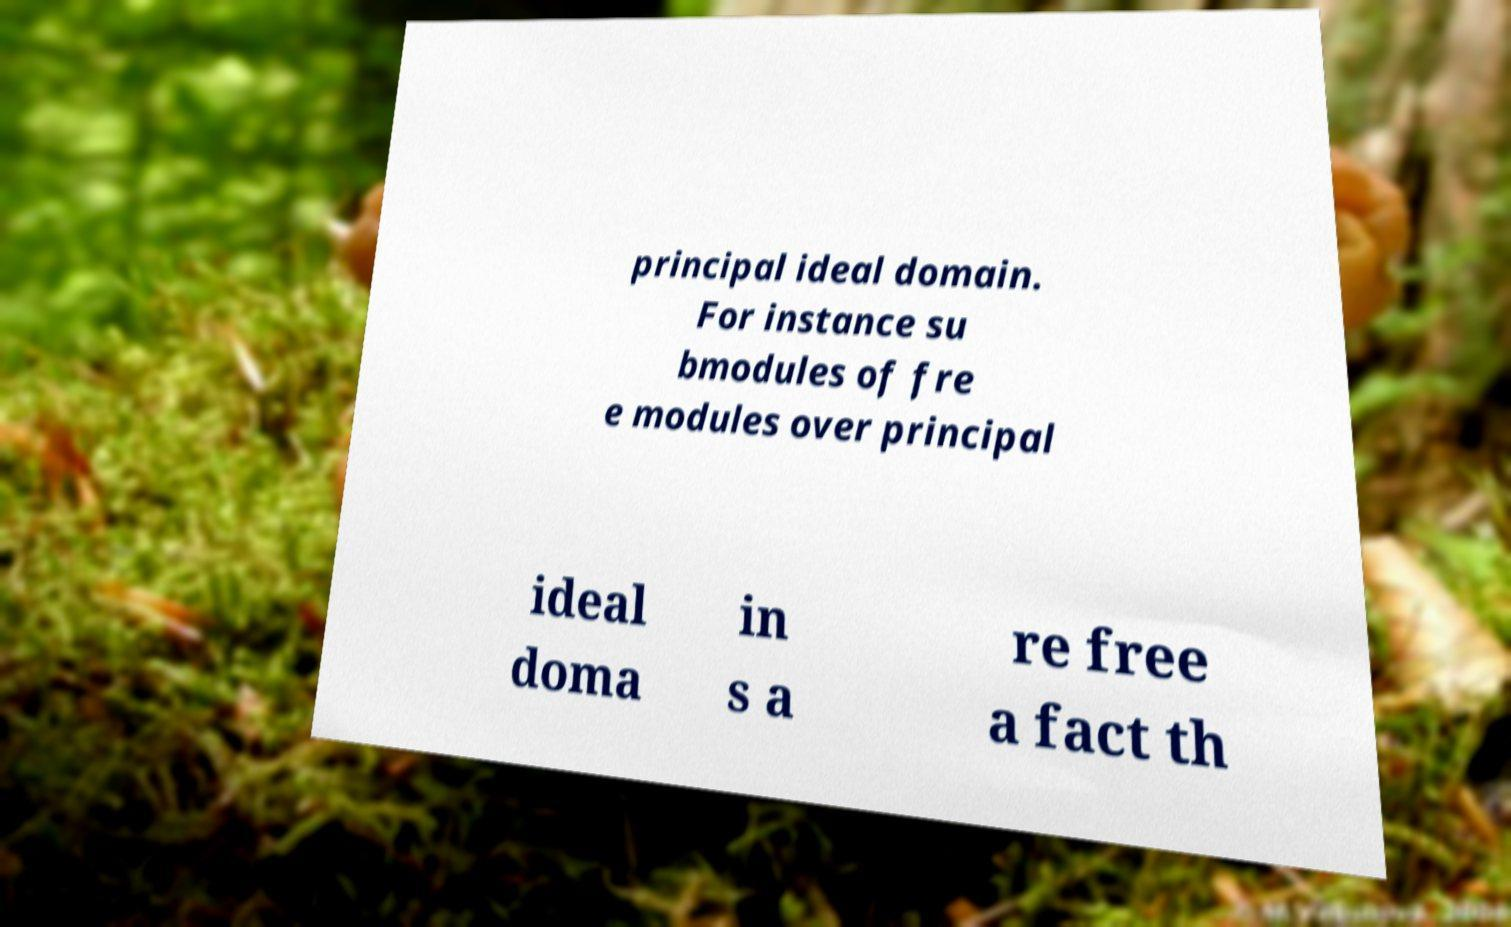Please identify and transcribe the text found in this image. principal ideal domain. For instance su bmodules of fre e modules over principal ideal doma in s a re free a fact th 